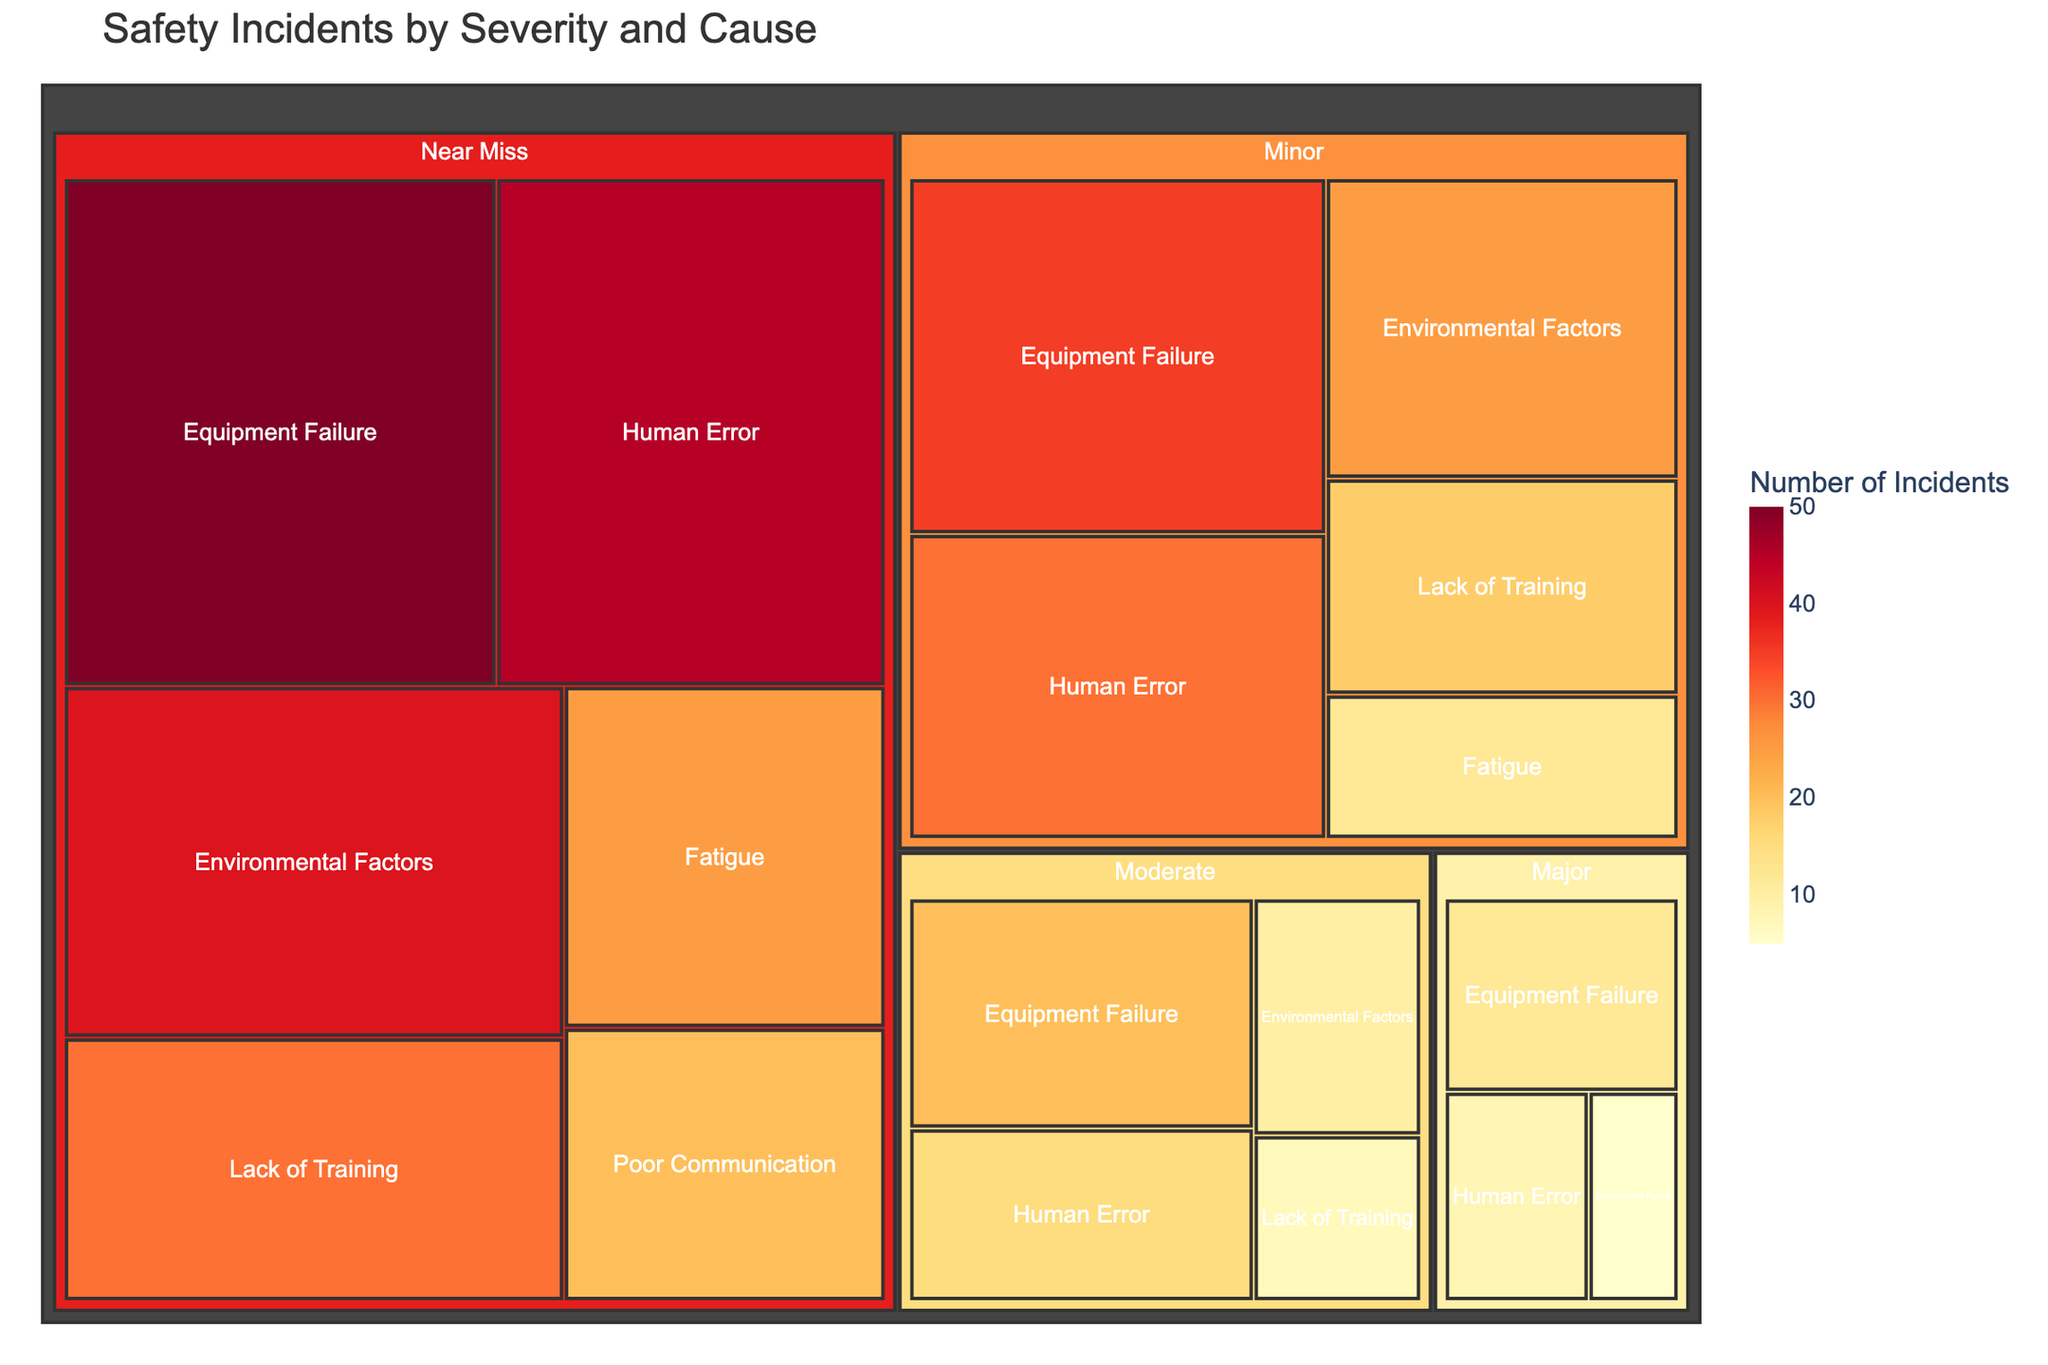What is the title of the treemap? The title of a treemap is typically displayed prominently at the top of the figure.
Answer: Safety Incidents by Severity and Cause What causative factor has the highest number of incidents under the 'Minor' severity category? To find this, look at the 'Minor' category and identify which causative factor rectangle has the largest size or the highest value labeled.
Answer: Equipment Failure How many total incidents were caused by 'Human Error'? Sum the incidents across all severity levels for the 'Human Error' category: Major (8) + Moderate (15) + Minor (30) + Near Miss (45).
Answer: 98 Which severity category has the least number of incidents for 'Environmental Factors'? Look at the 'Environmental Factors' in each severity category and compare their values to determine the lowest one.
Answer: Major What is the combined total number of incidents classified as 'Major'? Sum the incidents for all causative factors under the 'Major' severity: Equipment Failure (12) + Human Error (8) + Environmental Factors (5).
Answer: 25 Which causative factor appears only in the 'Near Miss' category but not in others? Identify the causative factor that is unique to 'Near Miss' by observing the list of causes.
Answer: Poor Communication How many total incidents were caused by 'Lack of Training' across all severity levels? Add the incidents in the 'Lack of Training' category from all severity levels: Moderate (7) + Minor (18) + Near Miss (30).
Answer: 55 Which severity category has the widest range of causative factors? By counting the distinct causative factors under each severity category: Major (3), Moderate (4), Minor (5), Near Miss (6).
Answer: Near Miss Which category has the highest number of incidents overall? Compare the total number of incidents across all severity categories by summing their respective incidents values.
Answer: Near Miss What is the difference between the number of 'Near Miss' and 'Major' incidents caused by 'Equipment Failure'? Find the difference by subtracting the number of 'Major' incidents (12) from 'Near Miss' incidents (50).
Answer: 38 